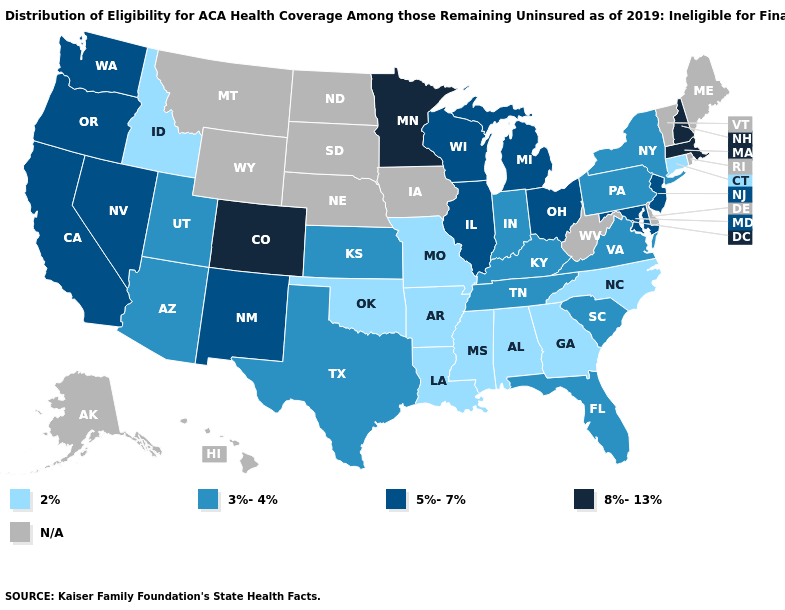Name the states that have a value in the range 3%-4%?
Concise answer only. Arizona, Florida, Indiana, Kansas, Kentucky, New York, Pennsylvania, South Carolina, Tennessee, Texas, Utah, Virginia. Which states have the lowest value in the South?
Short answer required. Alabama, Arkansas, Georgia, Louisiana, Mississippi, North Carolina, Oklahoma. Which states have the lowest value in the Northeast?
Write a very short answer. Connecticut. What is the value of New York?
Keep it brief. 3%-4%. What is the value of Nebraska?
Short answer required. N/A. Name the states that have a value in the range 8%-13%?
Give a very brief answer. Colorado, Massachusetts, Minnesota, New Hampshire. What is the value of Indiana?
Keep it brief. 3%-4%. Does Missouri have the lowest value in the MidWest?
Be succinct. Yes. What is the value of Delaware?
Answer briefly. N/A. What is the value of Michigan?
Quick response, please. 5%-7%. Which states have the highest value in the USA?
Give a very brief answer. Colorado, Massachusetts, Minnesota, New Hampshire. Which states hav the highest value in the West?
Be succinct. Colorado. What is the highest value in states that border Maryland?
Answer briefly. 3%-4%. 